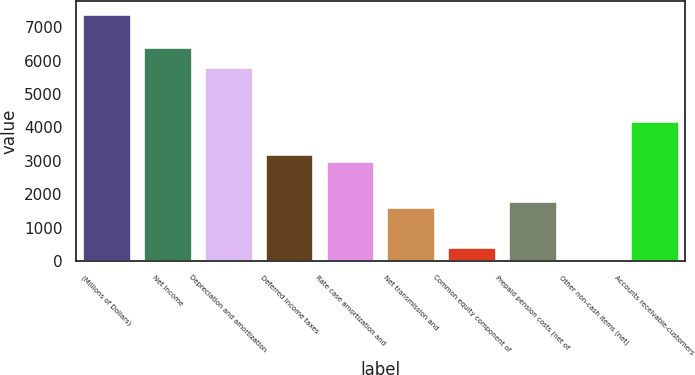<chart> <loc_0><loc_0><loc_500><loc_500><bar_chart><fcel>(Millions of Dollars)<fcel>Net income<fcel>Depreciation and amortization<fcel>Deferred income taxes<fcel>Rate case amortization and<fcel>Net transmission and<fcel>Common equity component of<fcel>Prepaid pension costs (net of<fcel>Other non-cash items (net)<fcel>Accounts receivable-customers<nl><fcel>7407.7<fcel>6407.2<fcel>5806.9<fcel>3205.6<fcel>3005.5<fcel>1604.8<fcel>404.2<fcel>1804.9<fcel>4<fcel>4206.1<nl></chart> 